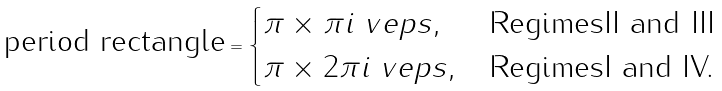<formula> <loc_0><loc_0><loc_500><loc_500>\text {period rectangle} = \begin{cases} \pi \times \pi i \ v e p s , & \text {RegimesII and III} \\ \pi \times 2 \pi i \ v e p s , & \text {RegimesI and IV.} \end{cases}</formula> 